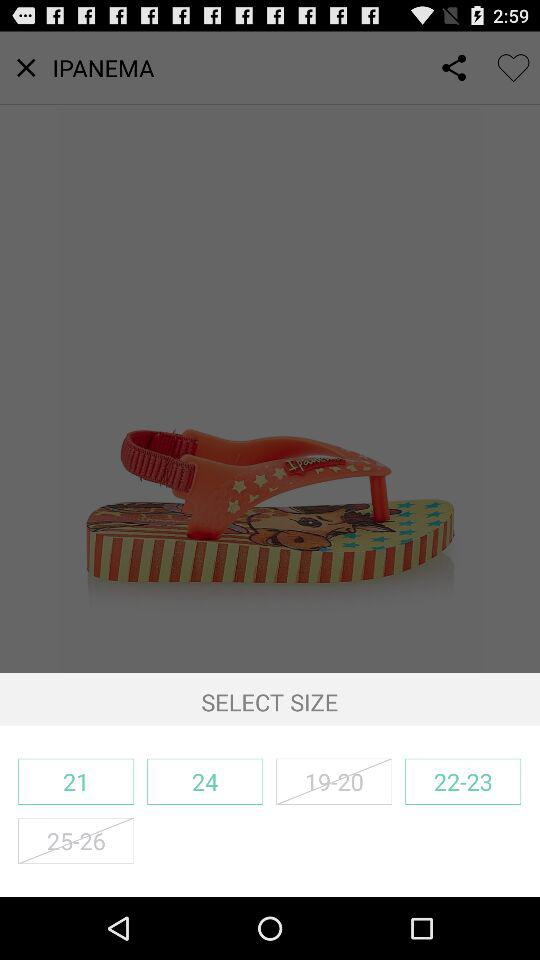What are the different available sizes? The different available sizes are "21", "24" and "22-23". 